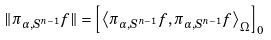<formula> <loc_0><loc_0><loc_500><loc_500>\| \pi _ { \alpha , S ^ { n - 1 } } f \| = \left [ \left \langle \pi _ { \alpha , S ^ { n - 1 } } f , \pi _ { \alpha , S ^ { n - 1 } } f \right \rangle _ { \Omega } \right ] _ { 0 }</formula> 